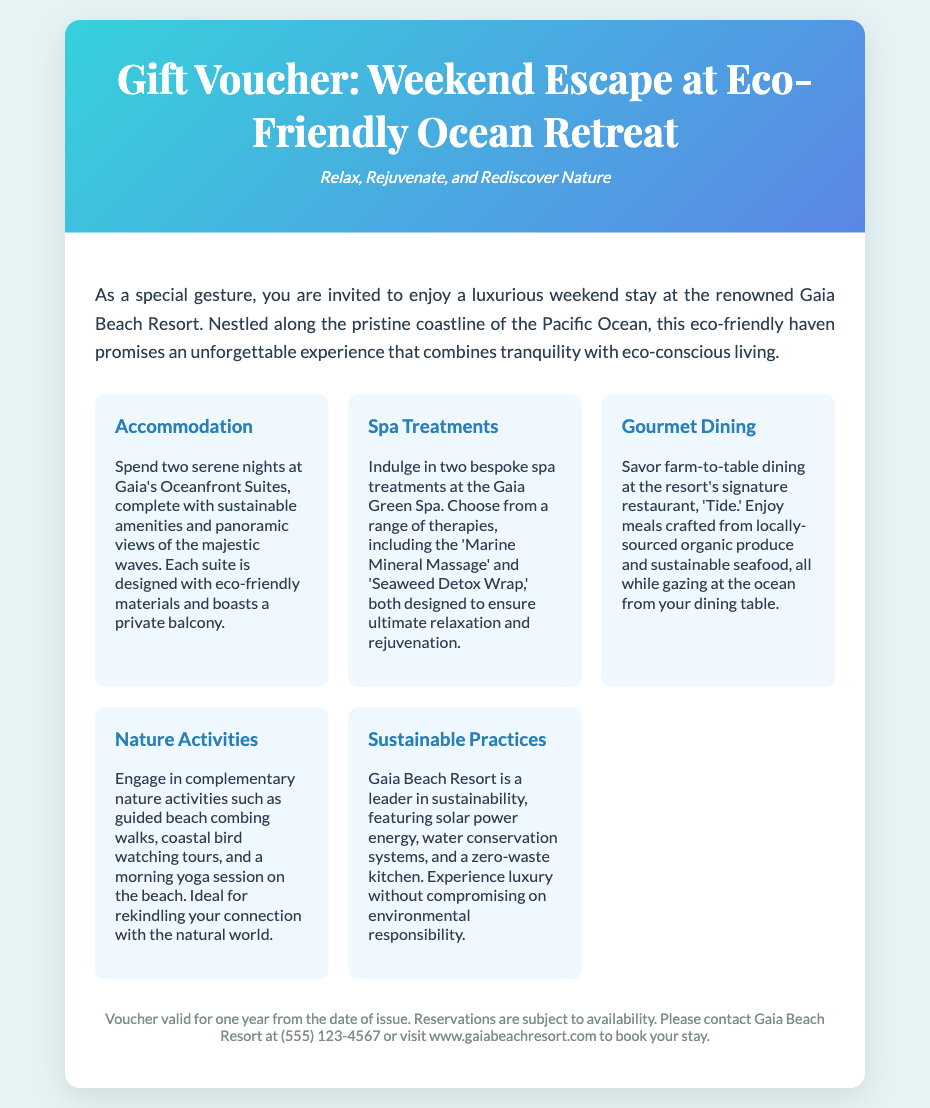What is the name of the resort? The document mentions the resort as "Gaia Beach Resort."
Answer: Gaia Beach Resort How long is the stay included in the voucher? The voucher includes "two serene nights" at the resort.
Answer: Two nights What type of massages are offered at the spa? The document lists "Marine Mineral Massage" and "Seaweed Detox Wrap" as the therapies available.
Answer: Marine Mineral Massage, Seaweed Detox Wrap What is the name of the resort's restaurant? The restaurant at the resort is named "Tide."
Answer: Tide What is the voucher's validity period? The fine print states that the voucher is valid for "one year from the date of issue."
Answer: One year What kind of activities are included? The document mentions "guided beach combing walks, coastal bird watching tours, and a morning yoga session."
Answer: Nature activities Which practices does the resort prioritize for sustainability? The resort features practices like "solar power energy, water conservation systems, and a zero-waste kitchen."
Answer: Sustainability practices What is required to book a stay? To book a stay, one must contact Gaia Beach Resort at the provided phone number or website.
Answer: Contact information 